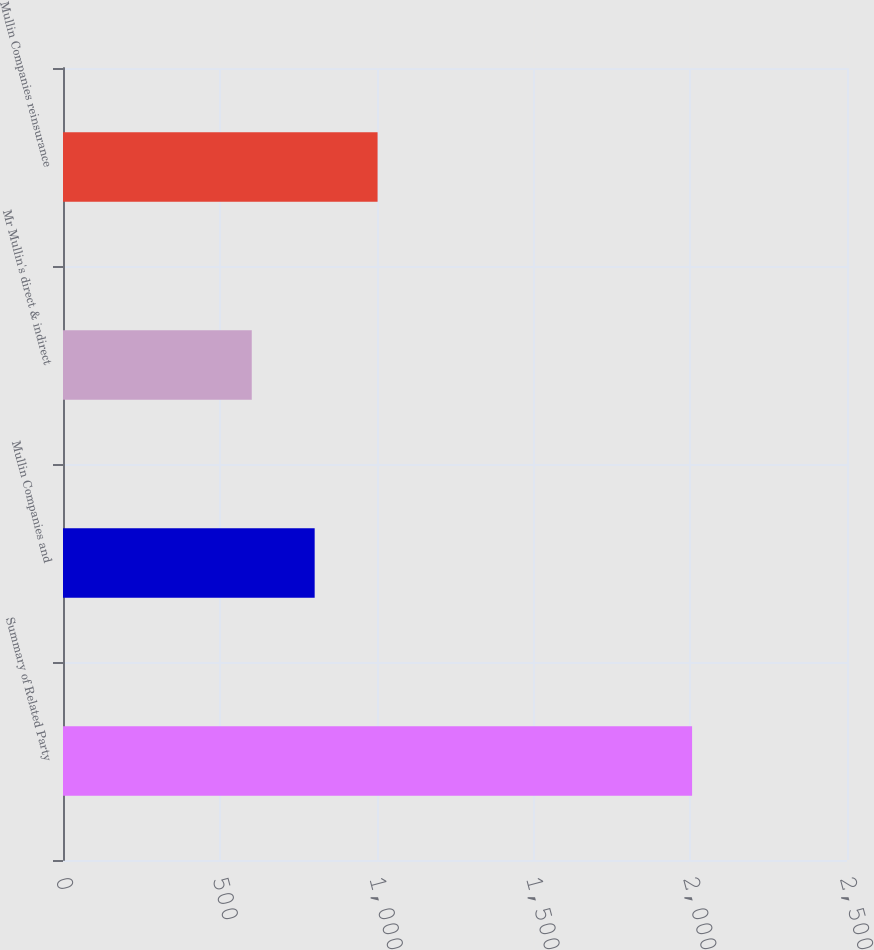Convert chart to OTSL. <chart><loc_0><loc_0><loc_500><loc_500><bar_chart><fcel>Summary of Related Party<fcel>Mullin Companies and<fcel>Mr Mullin's direct & indirect<fcel>Mullin Companies reinsurance<nl><fcel>2006<fcel>802.52<fcel>601.94<fcel>1003.1<nl></chart> 